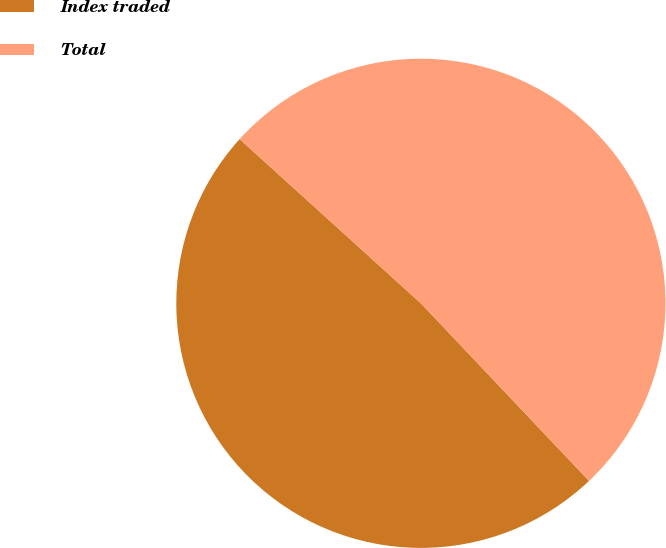Convert chart to OTSL. <chart><loc_0><loc_0><loc_500><loc_500><pie_chart><fcel>Index traded<fcel>Total<nl><fcel>48.78%<fcel>51.22%<nl></chart> 